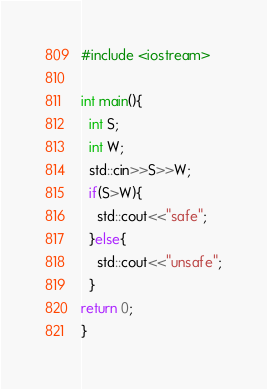Convert code to text. <code><loc_0><loc_0><loc_500><loc_500><_C++_>#include <iostream>

int main(){
  int S;
  int W;
  std::cin>>S>>W;
  if(S>W){
    std::cout<<"safe";
  }else{
    std::cout<<"unsafe";
  }
return 0;
}</code> 